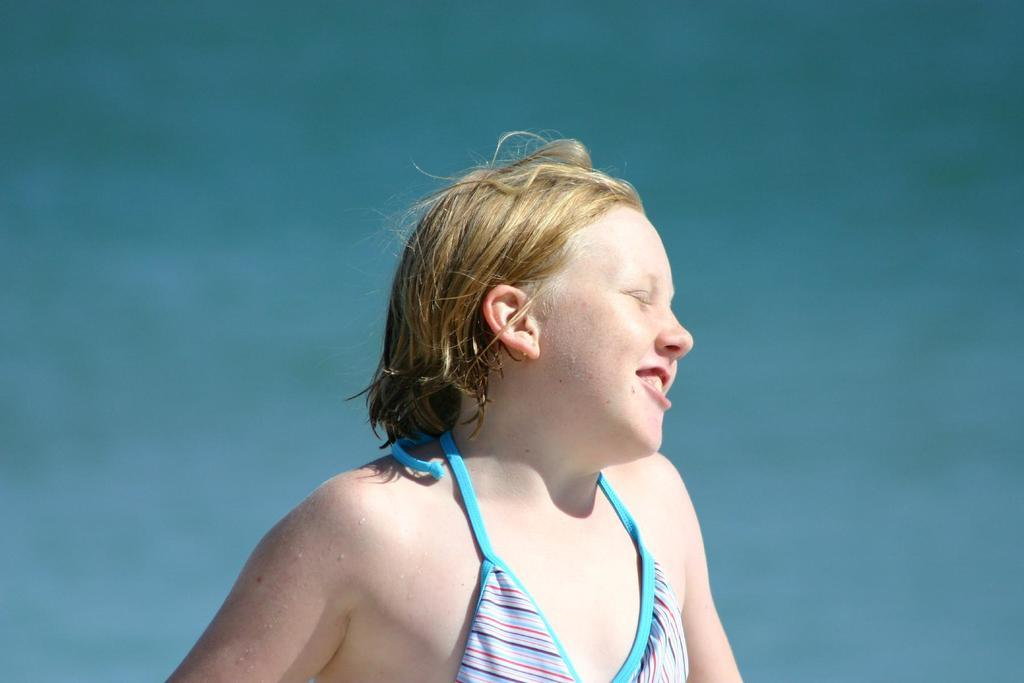What is the main subject of the image? There is a person in the image. What color is the background of the image? The background of the image is blue. What type of store can be seen in the background of the image? There is no store present in the image; the background is blue. How does the person in the image feel about the feeling of the dock? There is no dock present in the image, and the person's feelings cannot be determined from the image alone. 